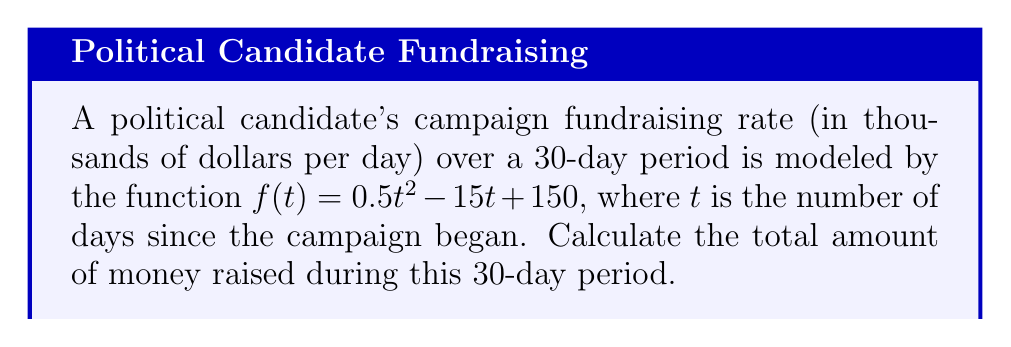Could you help me with this problem? To solve this problem, we need to integrate the given function over the interval [0, 30]. This will give us the area under the curve, which represents the total amount of money raised.

1) The integral we need to evaluate is:

   $$\int_0^{30} (0.5t^2 - 15t + 150) dt$$

2) Integrate each term:
   
   $$\left[\frac{0.5t^3}{3} - \frac{15t^2}{2} + 150t\right]_0^{30}$$

3) Evaluate at the upper and lower bounds:

   $$\left(\frac{0.5(30^3)}{3} - \frac{15(30^2)}{2} + 150(30)\right) - \left(\frac{0.5(0^3)}{3} - \frac{15(0^2)}{2} + 150(0)\right)$$

4) Simplify:

   $$\left(4500 - 6750 + 4500\right) - (0)$$

5) Calculate the final result:

   $$2250$$

6) Since the function was in thousands of dollars, the actual amount is $2,250,000.
Answer: $2,250,000 